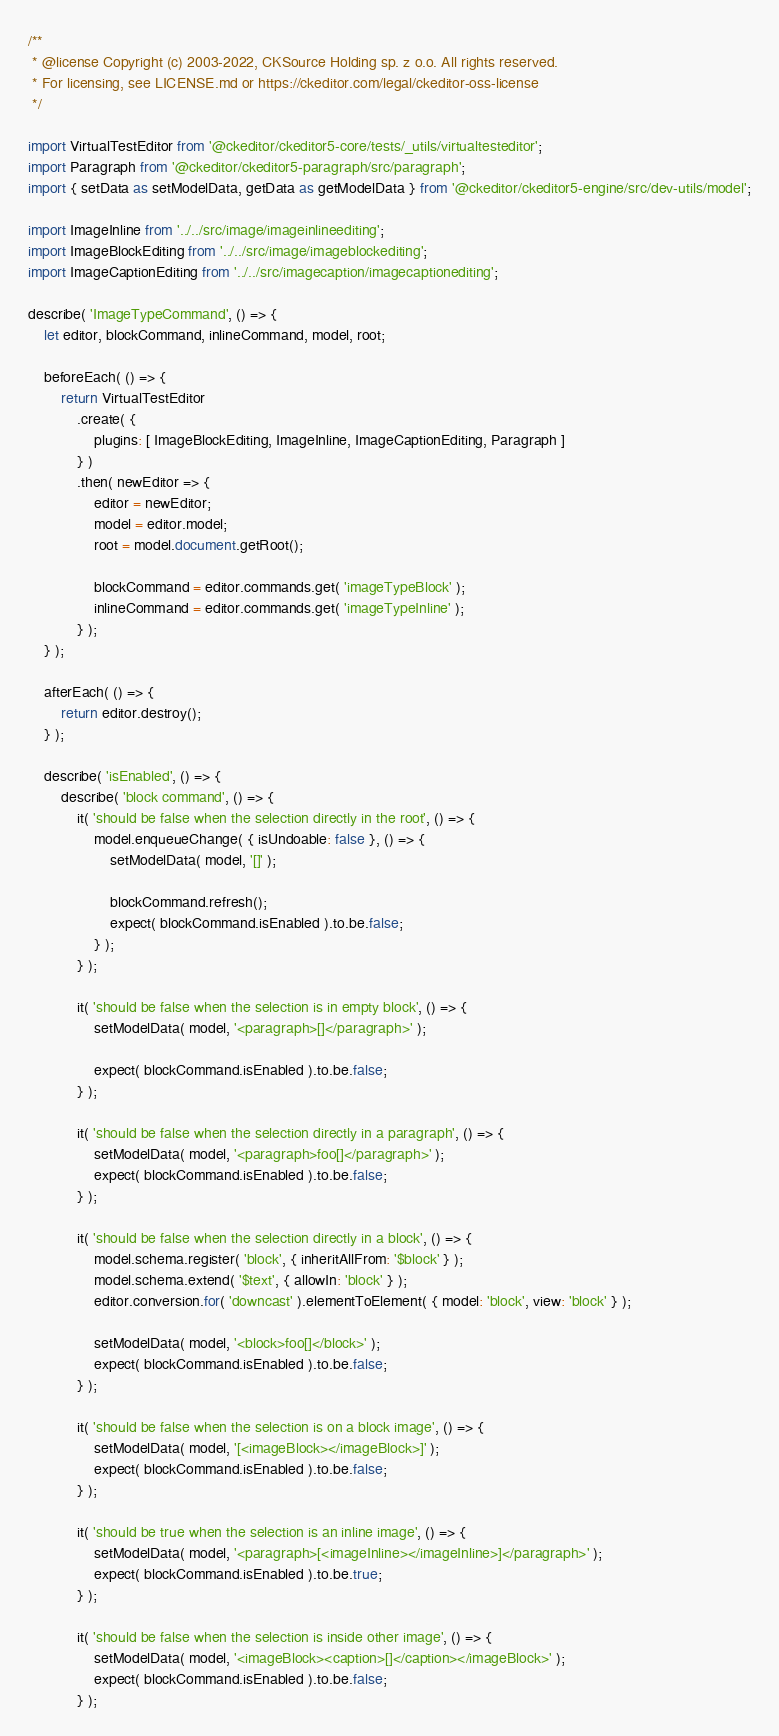<code> <loc_0><loc_0><loc_500><loc_500><_JavaScript_>/**
 * @license Copyright (c) 2003-2022, CKSource Holding sp. z o.o. All rights reserved.
 * For licensing, see LICENSE.md or https://ckeditor.com/legal/ckeditor-oss-license
 */

import VirtualTestEditor from '@ckeditor/ckeditor5-core/tests/_utils/virtualtesteditor';
import Paragraph from '@ckeditor/ckeditor5-paragraph/src/paragraph';
import { setData as setModelData, getData as getModelData } from '@ckeditor/ckeditor5-engine/src/dev-utils/model';

import ImageInline from '../../src/image/imageinlineediting';
import ImageBlockEditing from '../../src/image/imageblockediting';
import ImageCaptionEditing from '../../src/imagecaption/imagecaptionediting';

describe( 'ImageTypeCommand', () => {
	let editor, blockCommand, inlineCommand, model, root;

	beforeEach( () => {
		return VirtualTestEditor
			.create( {
				plugins: [ ImageBlockEditing, ImageInline, ImageCaptionEditing, Paragraph ]
			} )
			.then( newEditor => {
				editor = newEditor;
				model = editor.model;
				root = model.document.getRoot();

				blockCommand = editor.commands.get( 'imageTypeBlock' );
				inlineCommand = editor.commands.get( 'imageTypeInline' );
			} );
	} );

	afterEach( () => {
		return editor.destroy();
	} );

	describe( 'isEnabled', () => {
		describe( 'block command', () => {
			it( 'should be false when the selection directly in the root', () => {
				model.enqueueChange( { isUndoable: false }, () => {
					setModelData( model, '[]' );

					blockCommand.refresh();
					expect( blockCommand.isEnabled ).to.be.false;
				} );
			} );

			it( 'should be false when the selection is in empty block', () => {
				setModelData( model, '<paragraph>[]</paragraph>' );

				expect( blockCommand.isEnabled ).to.be.false;
			} );

			it( 'should be false when the selection directly in a paragraph', () => {
				setModelData( model, '<paragraph>foo[]</paragraph>' );
				expect( blockCommand.isEnabled ).to.be.false;
			} );

			it( 'should be false when the selection directly in a block', () => {
				model.schema.register( 'block', { inheritAllFrom: '$block' } );
				model.schema.extend( '$text', { allowIn: 'block' } );
				editor.conversion.for( 'downcast' ).elementToElement( { model: 'block', view: 'block' } );

				setModelData( model, '<block>foo[]</block>' );
				expect( blockCommand.isEnabled ).to.be.false;
			} );

			it( 'should be false when the selection is on a block image', () => {
				setModelData( model, '[<imageBlock></imageBlock>]' );
				expect( blockCommand.isEnabled ).to.be.false;
			} );

			it( 'should be true when the selection is an inline image', () => {
				setModelData( model, '<paragraph>[<imageInline></imageInline>]</paragraph>' );
				expect( blockCommand.isEnabled ).to.be.true;
			} );

			it( 'should be false when the selection is inside other image', () => {
				setModelData( model, '<imageBlock><caption>[]</caption></imageBlock>' );
				expect( blockCommand.isEnabled ).to.be.false;
			} );
</code> 